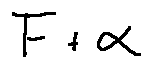<formula> <loc_0><loc_0><loc_500><loc_500>F + \alpha</formula> 